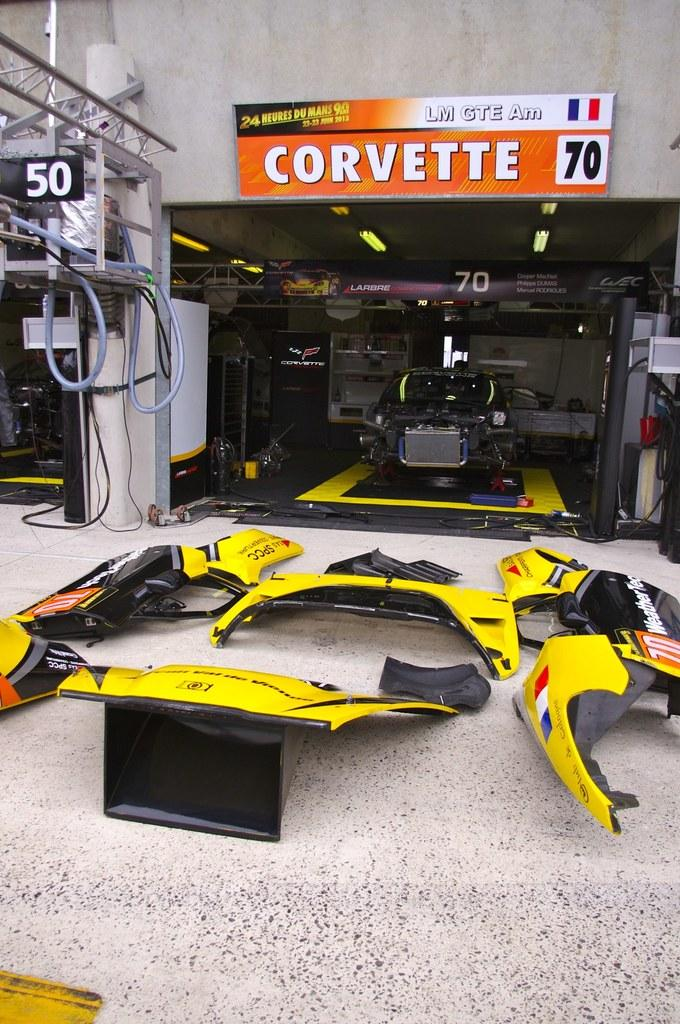What type of objects can be seen in the image that are related to a vehicle? There are parts of a vehicle in the image. What other objects can be seen in the image besides the vehicle parts? There is a pipe, cables, boards, and a wall visible in the image. What is located in the background of the image? In the background of the image, there is a machine on a platform, a board, and other objects. What type of quiver is visible in the image? There is no quiver present in the image. How does the balance of the machine on the platform affect the other objects in the image? The balance of the machine on the platform is not mentioned in the image, and therefore its effect on other objects cannot be determined. 